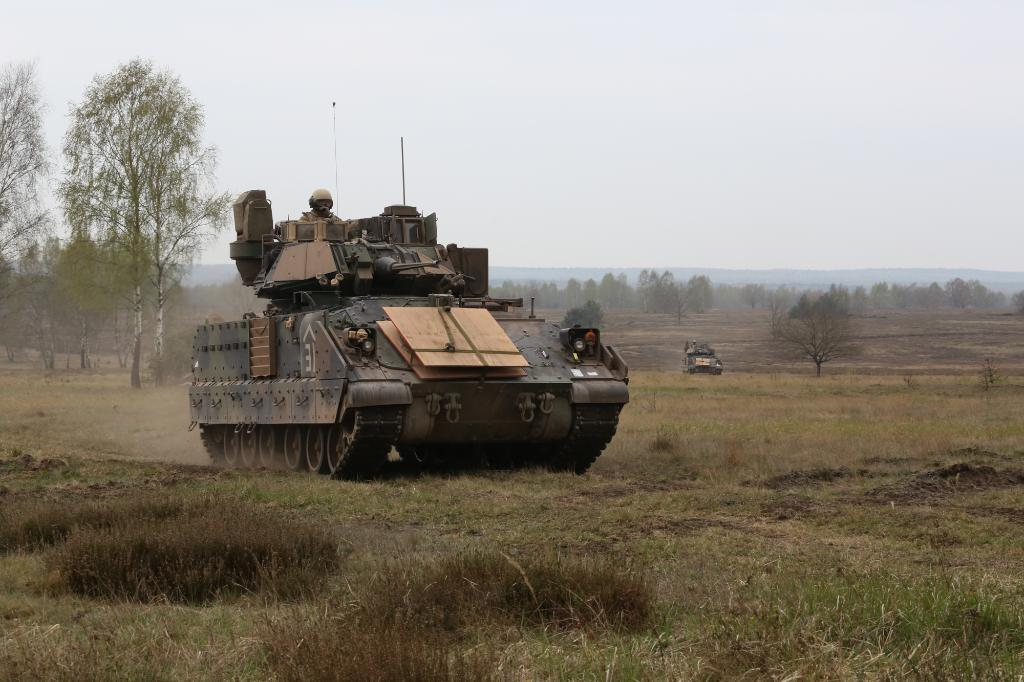What is the main subject of the image? The main subject of the image is a military tanker. Where is the military tanker located? The military tanker is on the grass. What can be seen in the background of the image? There are trees and another military tanker in the background of the image. What is visible at the top of the image? The sky is visible in the background of the image. What type of rings can be seen on the creature in the image? There is no creature present in the image, and therefore no rings can be observed. What brand of toothpaste is being used by the military tanker in the image? Military tankers do not use toothpaste, and there is no toothpaste present in the image. 